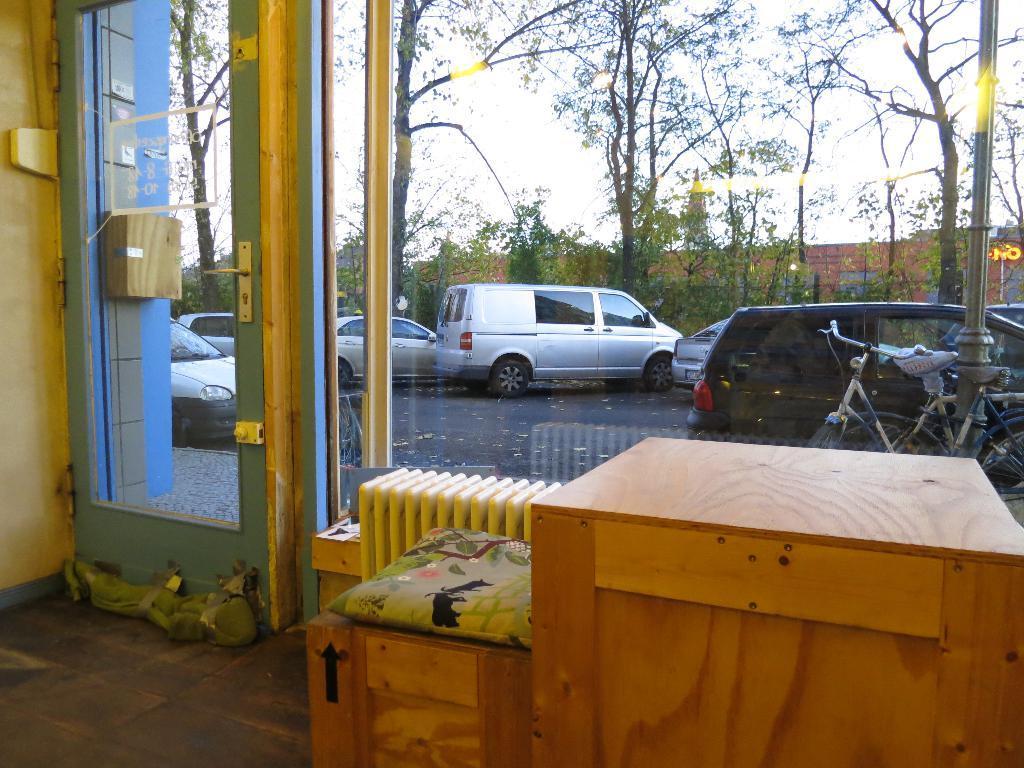In one or two sentences, can you explain what this image depicts? This is the picture of a room. In the foreground there is a pillow and there is a table. On the left side of the image there is a door. Behind the door there are vehicles on the road and there is a building and there are trees. At the top there is sky. At the bottom there is a road. 